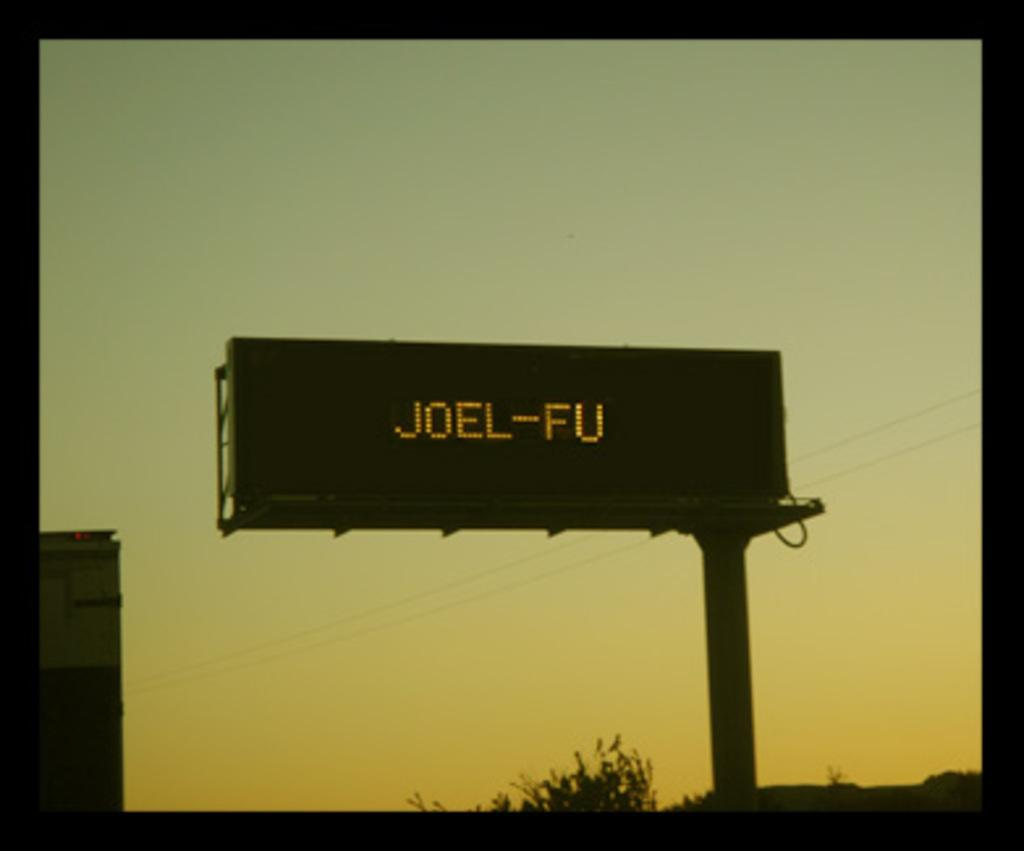<image>
Summarize the visual content of the image. Sunrise or sunset background with a billboard that says Joel-FU 